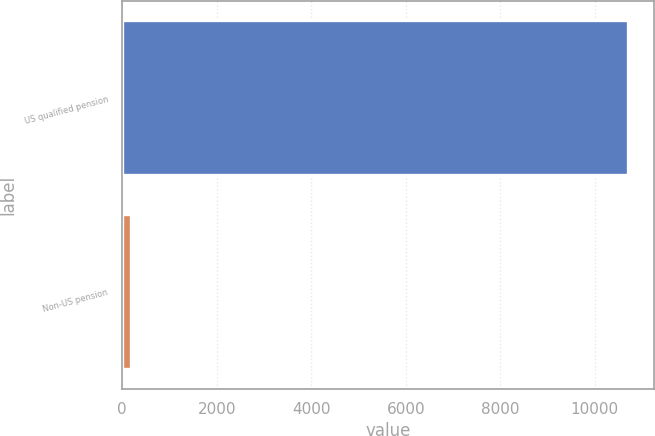<chart> <loc_0><loc_0><loc_500><loc_500><bar_chart><fcel>US qualified pension<fcel>Non-US pension<nl><fcel>10706<fcel>181<nl></chart> 